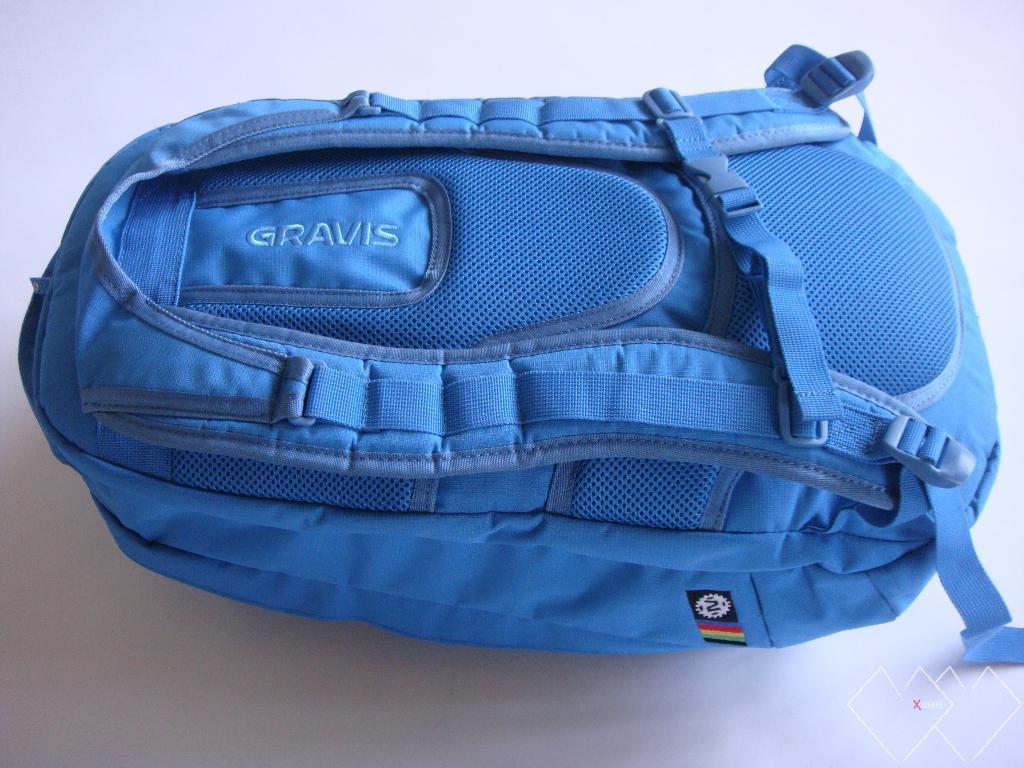Describe this image in one or two sentences. In this image I can see a blue colored back pack bag with a clutch and there is a colored label attached to the bag. 